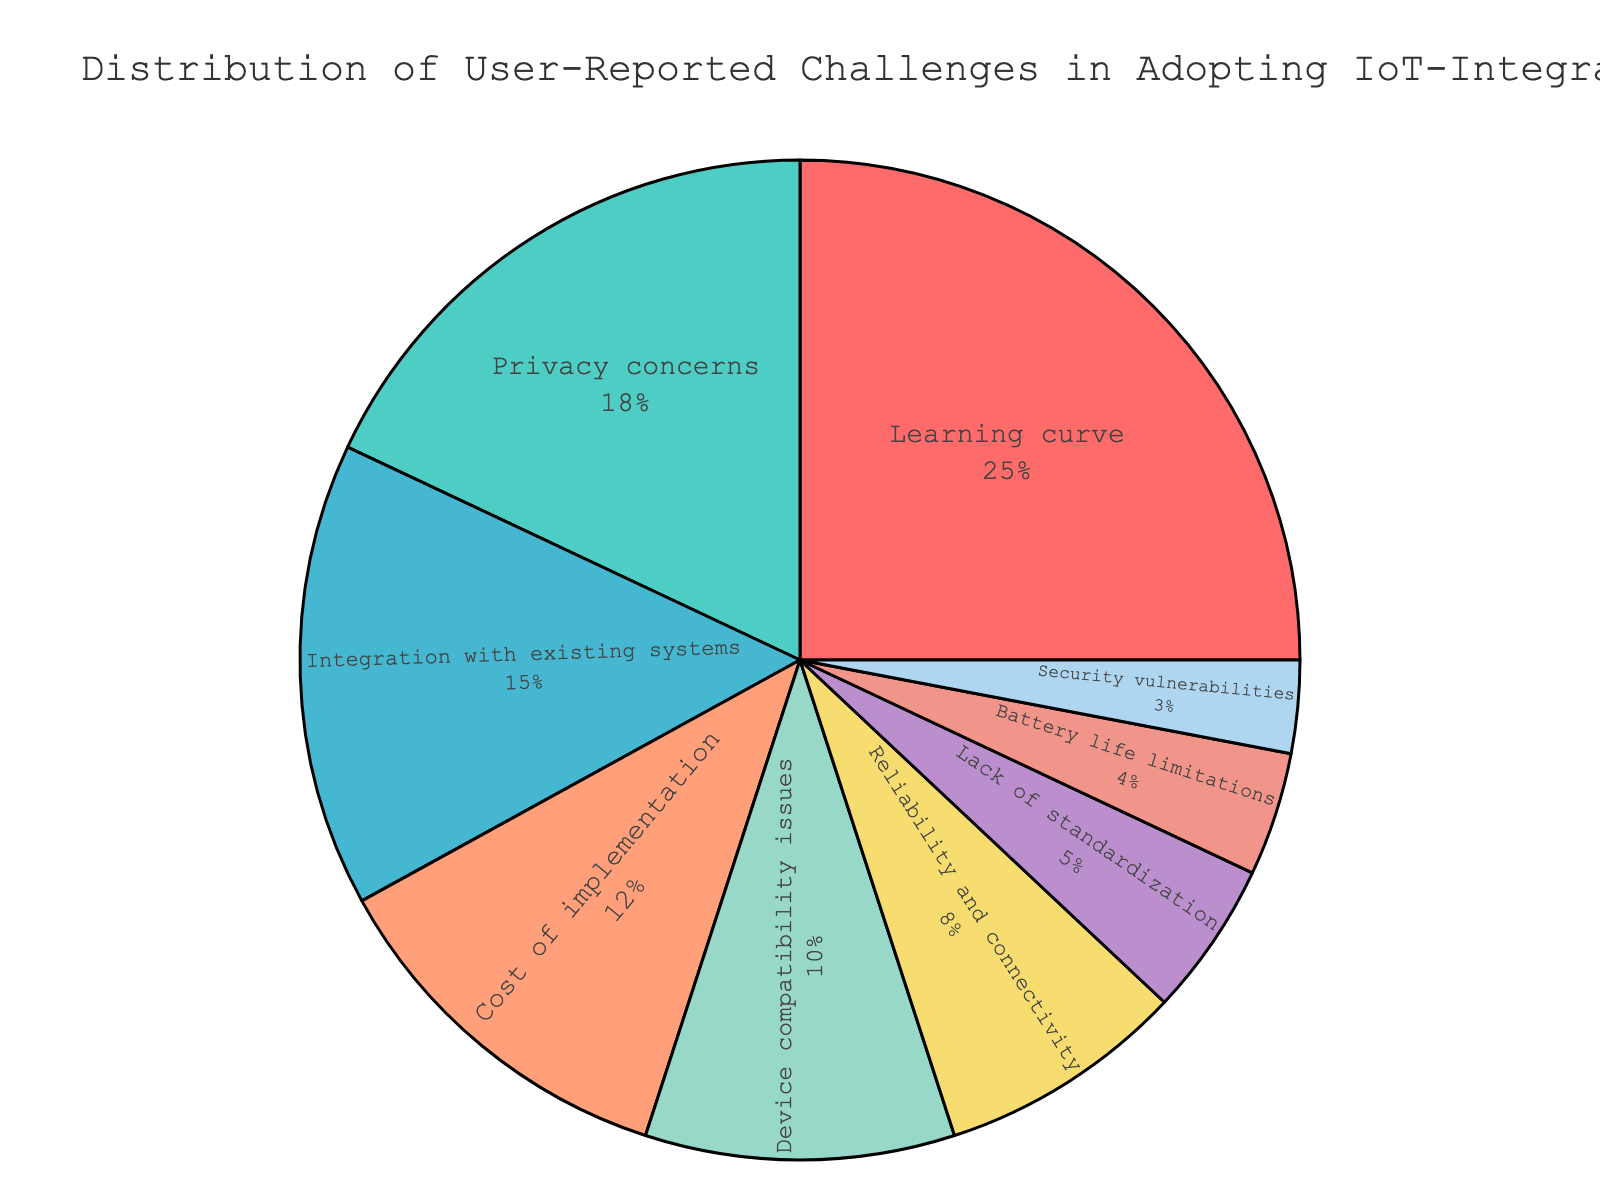What category represents the highest percentage of user-reported challenges? To determine the category with the highest percentage, we need to look at the segment with the largest area in the pie chart. The "Learning curve" segment is the largest, indicating it has the highest percentage.
Answer: Learning curve How much larger is the percentage of "Privacy concerns" compared to "Battery life limitations"? To find this, subtract the percentage for "Battery life limitations" from the percentage for "Privacy concerns": 18% - 4% = 14%.
Answer: 14% According to the pie chart, what is the most frequent user-reported challenge related to IoT-integrated interfaces? The pie chart shows that the "Learning curve" takes up the largest portion of the chart, signifying it is the most frequent challenge reported by users.
Answer: Learning curve Which category has a similar percentage to "Integration with existing systems"? By examining the chart, we see that "Integration with existing systems" is 15%, and "Cost of implementation," at 12%, is the category closest to that value.
Answer: Cost of implementation What is the combined percentage of users reporting "Device compatibility issues" and "Reliability and connectivity"? Adding the percentages for "Device compatibility issues" (10%) and "Reliability and connectivity" (8%) yields 10% + 8% = 18%.
Answer: 18% Identify two categories that together constitute about one-third of the total percentage. One third of 100% is approximately 33%. Adding "Learning curve" (25%) and "Reliability and connectivity" (8%) yields 25% + 8% = 33%.
Answer: Learning curve, Reliability and connectivity What is the total percentage of challenges reported about reliability and standardization? Summing the percentages for "Reliability and connectivity" (8%) and "Lack of standardization" (5%) results in 8% + 5% = 13%.
Answer: 13% Which category has the least reported challenges, and what is its percentage? The smallest segment in the pie chart is "Security vulnerabilities," indicating it has the least reported challenges with a percentage of 3%.
Answer: Security vulnerabilities, 3% Compare the percentages of "Cost of implementation" and "Device compatibility issues." Which is higher? Checking the pie chart, "Cost of implementation" has a percentage of 12%, while "Device compatibility issues" has 10%. Thus, "Cost of implementation" is higher.
Answer: Cost of implementation What percentage of users reported "Privacy concerns" or "Reliability and connectivity"? To find this, sum the percentages for "Privacy concerns" (18%) and "Reliability and connectivity" (8%): 18% + 8% = 26%.
Answer: 26% 